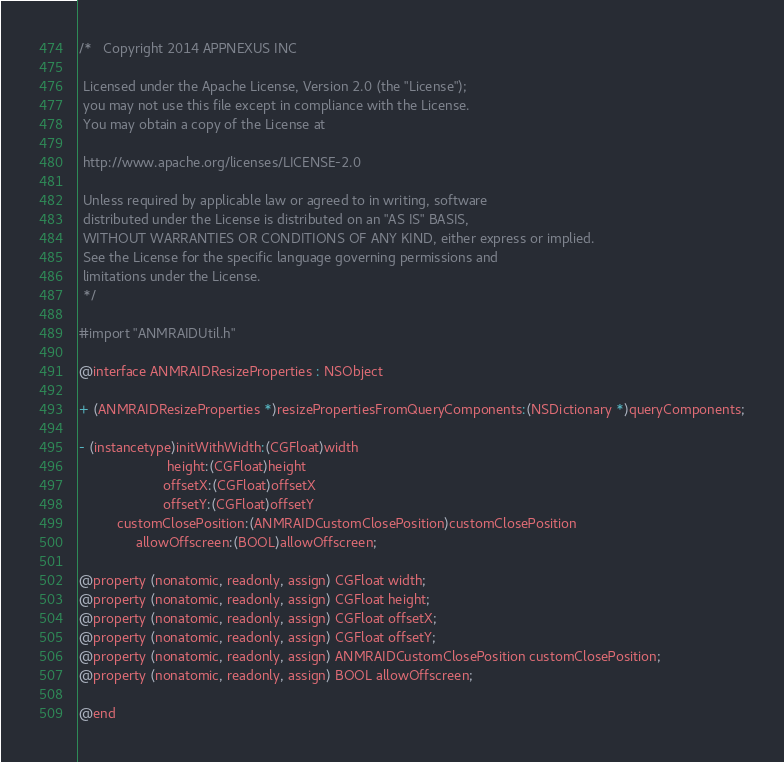<code> <loc_0><loc_0><loc_500><loc_500><_C_>/*   Copyright 2014 APPNEXUS INC
 
 Licensed under the Apache License, Version 2.0 (the "License");
 you may not use this file except in compliance with the License.
 You may obtain a copy of the License at
 
 http://www.apache.org/licenses/LICENSE-2.0
 
 Unless required by applicable law or agreed to in writing, software
 distributed under the License is distributed on an "AS IS" BASIS,
 WITHOUT WARRANTIES OR CONDITIONS OF ANY KIND, either express or implied.
 See the License for the specific language governing permissions and
 limitations under the License.
 */

#import "ANMRAIDUtil.h"

@interface ANMRAIDResizeProperties : NSObject

+ (ANMRAIDResizeProperties *)resizePropertiesFromQueryComponents:(NSDictionary *)queryComponents;

- (instancetype)initWithWidth:(CGFloat)width
                       height:(CGFloat)height
                      offsetX:(CGFloat)offsetX
                      offsetY:(CGFloat)offsetY
          customClosePosition:(ANMRAIDCustomClosePosition)customClosePosition
               allowOffscreen:(BOOL)allowOffscreen;

@property (nonatomic, readonly, assign) CGFloat width;
@property (nonatomic, readonly, assign) CGFloat height;
@property (nonatomic, readonly, assign) CGFloat offsetX;
@property (nonatomic, readonly, assign) CGFloat offsetY;
@property (nonatomic, readonly, assign) ANMRAIDCustomClosePosition customClosePosition;
@property (nonatomic, readonly, assign) BOOL allowOffscreen;

@end</code> 